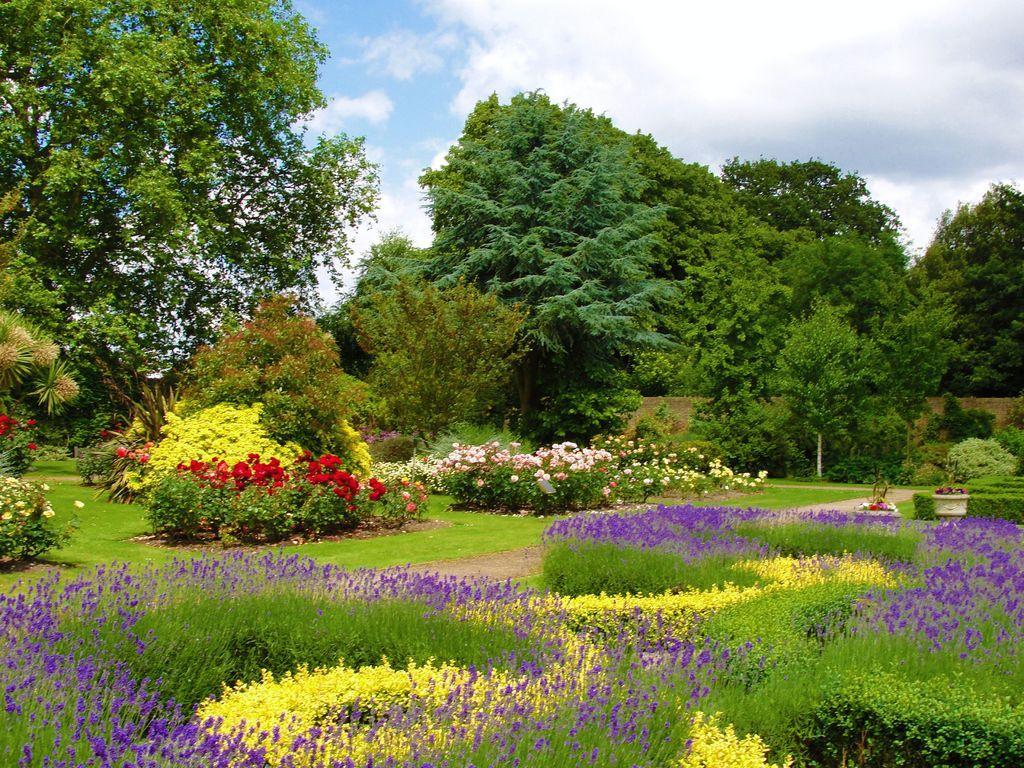How would you summarize this image in a sentence or two? As we can see in the image there is grass, flowers, plants, trees, wall, sky and clouds. 